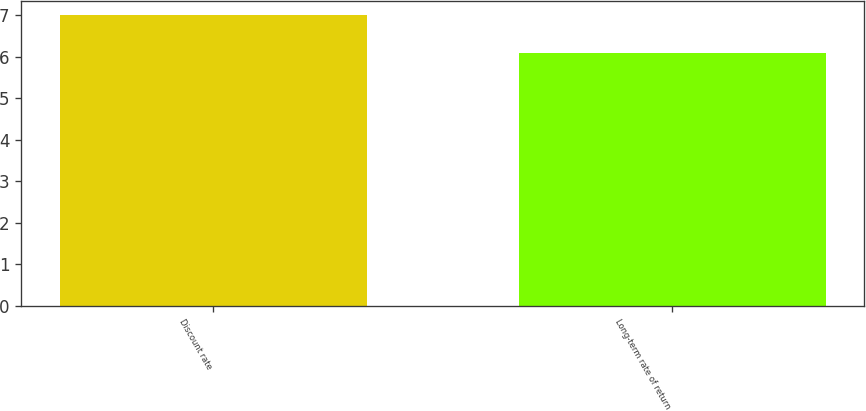<chart> <loc_0><loc_0><loc_500><loc_500><bar_chart><fcel>Discount rate<fcel>Long-term rate of return<nl><fcel>7<fcel>6.1<nl></chart> 